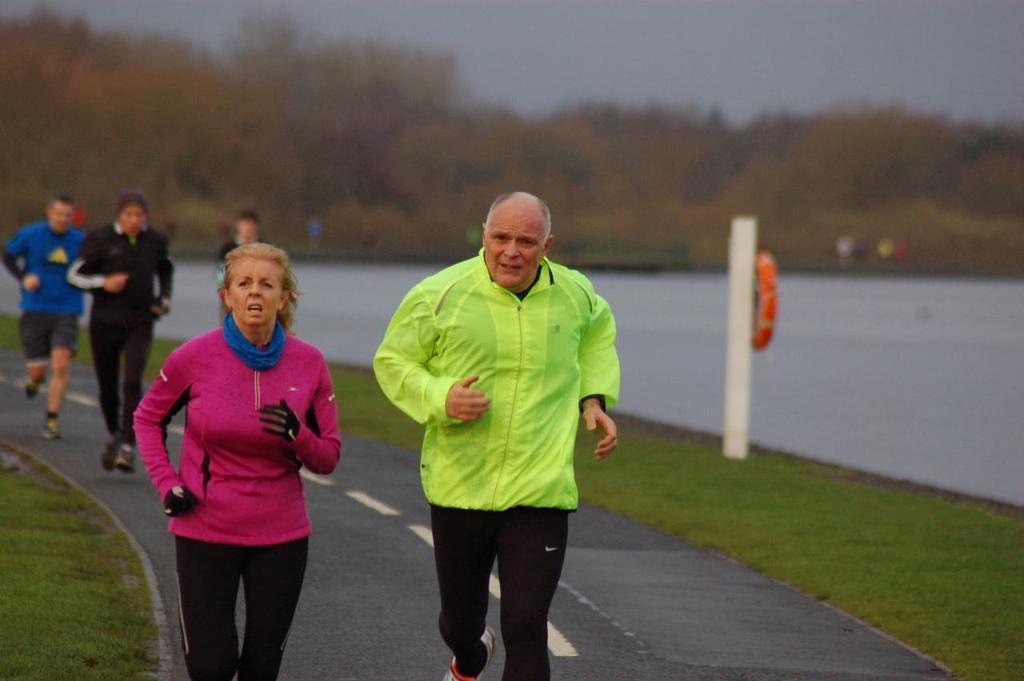Please provide a concise description of this image. In this image we can see few people jogging on the road. On the sides there's grass on the ground. On the right side there is water. In the background there are trees and sky. Also there is a pole with a tube. 